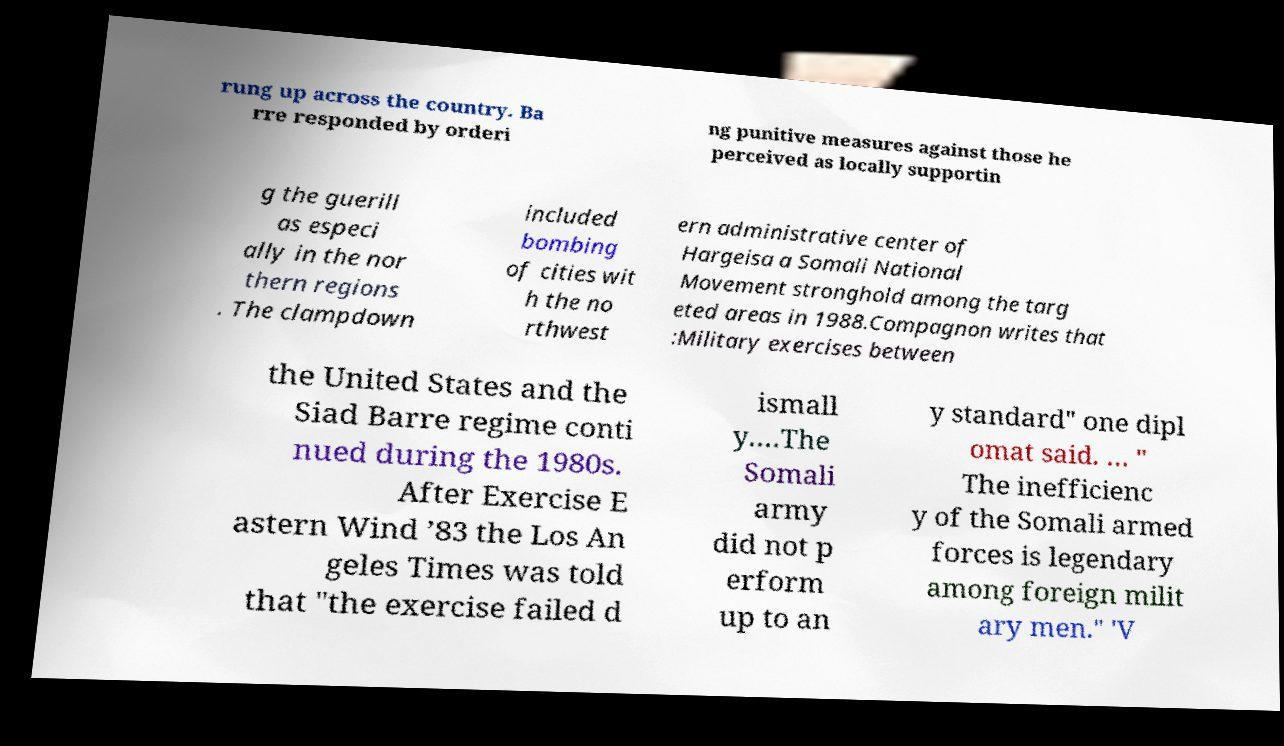Can you accurately transcribe the text from the provided image for me? rung up across the country. Ba rre responded by orderi ng punitive measures against those he perceived as locally supportin g the guerill as especi ally in the nor thern regions . The clampdown included bombing of cities wit h the no rthwest ern administrative center of Hargeisa a Somali National Movement stronghold among the targ eted areas in 1988.Compagnon writes that :Military exercises between the United States and the Siad Barre regime conti nued during the 1980s. After Exercise E astern Wind ’83 the Los An geles Times was told that "the exercise failed d ismall y.…The Somali army did not p erform up to an y standard" one dipl omat said. … " The inefficienc y of the Somali armed forces is legendary among foreign milit ary men." 'V 